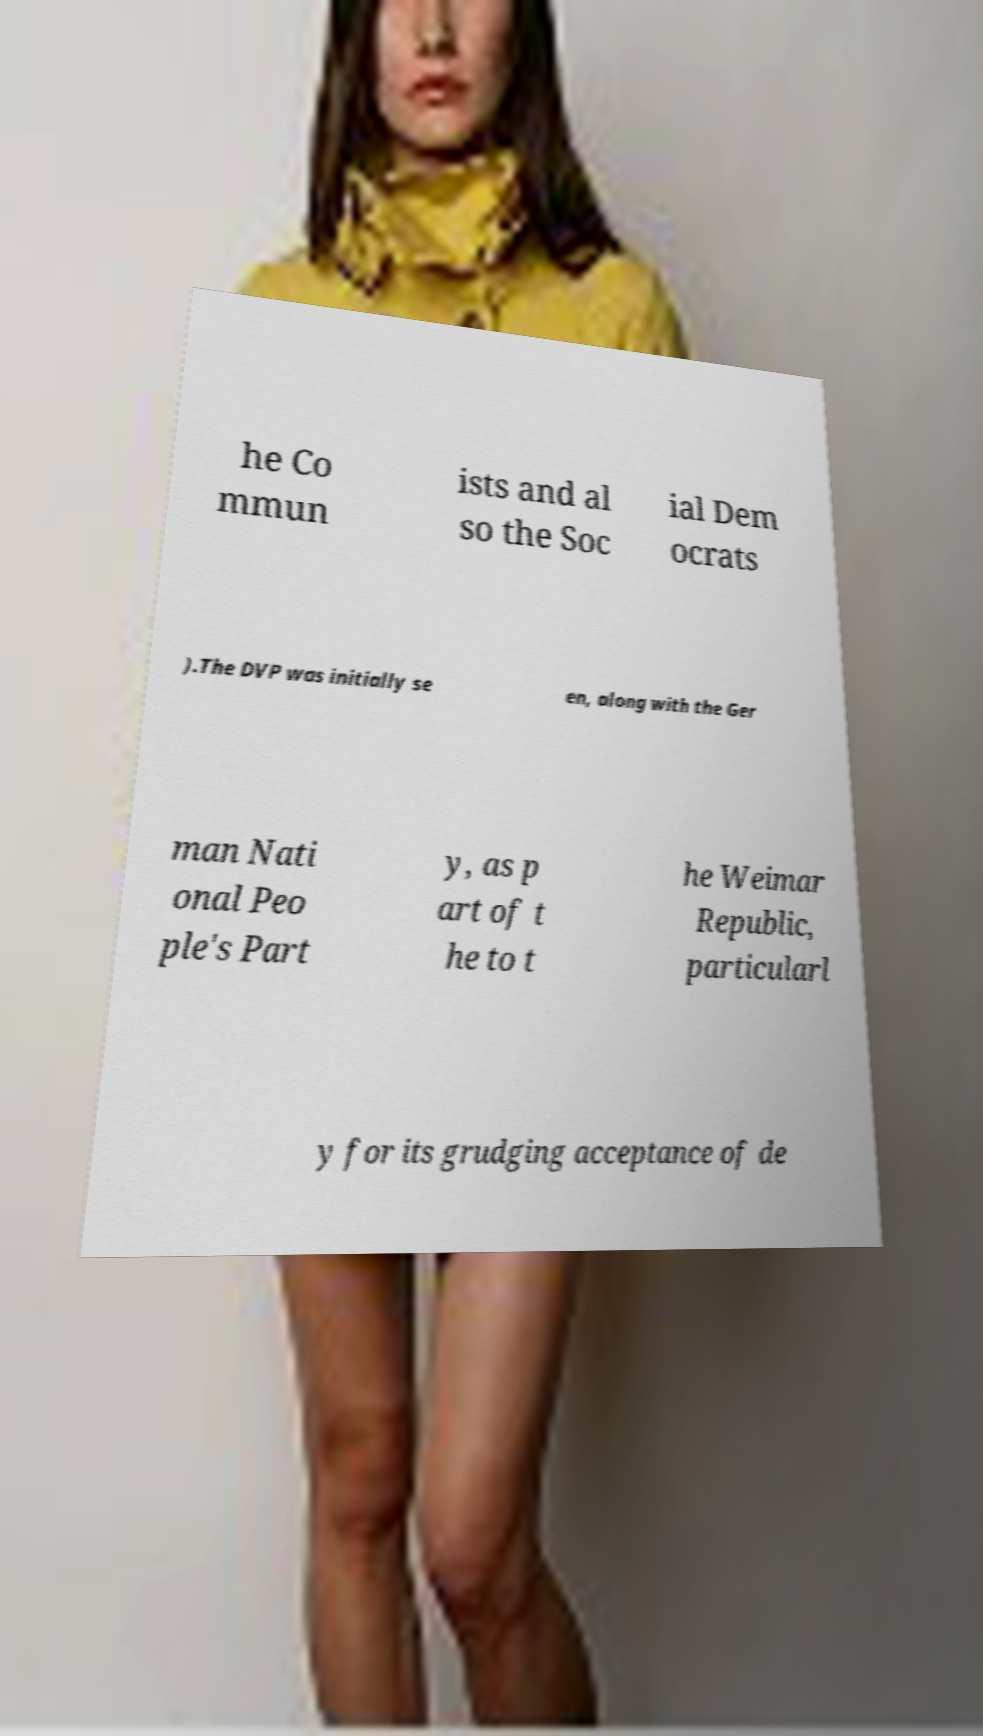Could you assist in decoding the text presented in this image and type it out clearly? he Co mmun ists and al so the Soc ial Dem ocrats ).The DVP was initially se en, along with the Ger man Nati onal Peo ple's Part y, as p art of t he to t he Weimar Republic, particularl y for its grudging acceptance of de 